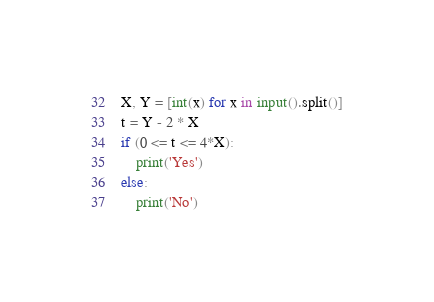Convert code to text. <code><loc_0><loc_0><loc_500><loc_500><_Python_>X, Y = [int(x) for x in input().split()]
t = Y - 2 * X
if (0 <= t <= 4*X):
    print('Yes')
else:
    print('No')
</code> 